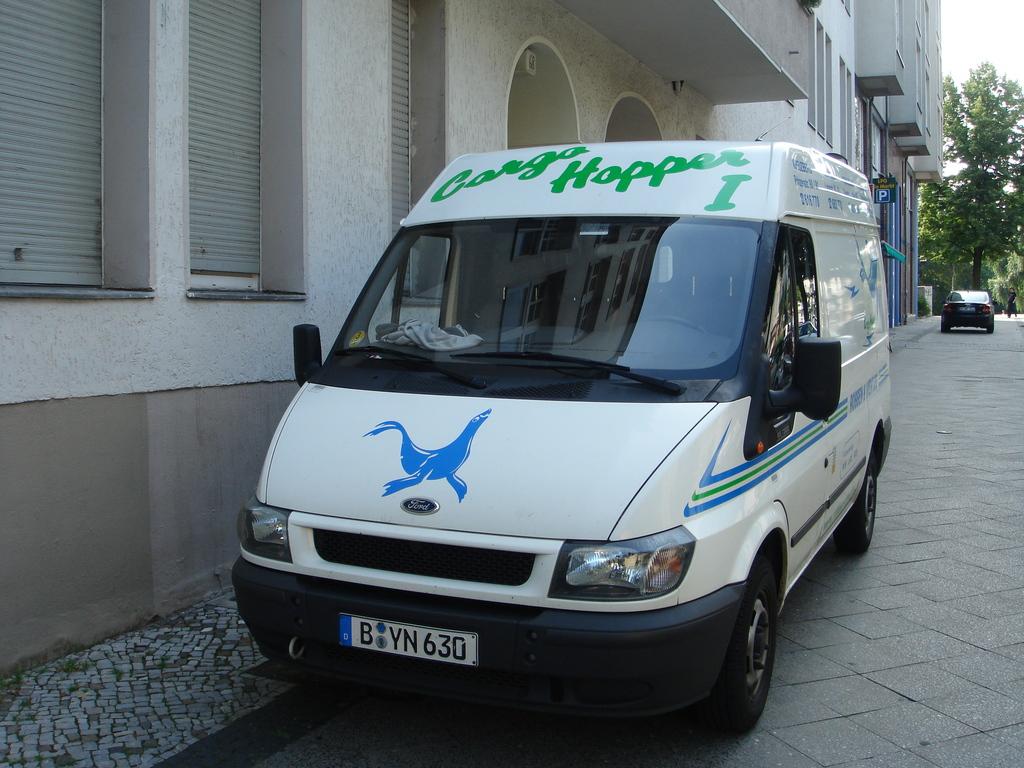The green lettering reads?
Keep it short and to the point. Cargo hopper i. 